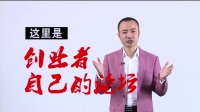Write a detailed description of this image, do not forget about the texts on it if they exist. Also, do not forget to mention the type / style of the image. This image appears to be a professional still, possibly from a promotional or educational context. Featured centrally is a middle-aged man striking an approachable pose, with his hands extended outward as if mid-presentation or conducting. He wears a distinctively stylish pink blazer over a crisp white shirt, invoking a sense of confidence and flair. His facial expression exudes friendliness with a gentle smile and an inviting demeanor, suggesting that he may be a speaker or a host. Dominating the image in the background are bold Chinese characters; illustrated in black on the top left and in a striking red with calligraphy-style strokes overlaying part of the image to the right of the man. The red text captures attention and may allude to a specific theme or message intended for the viewer. Although the image itself does not reveal the exact nature of the content, the combination of traditional text and the man's modern attire bridges cultural elements, hinting at an engagement with a Chinese-speaking audience. 